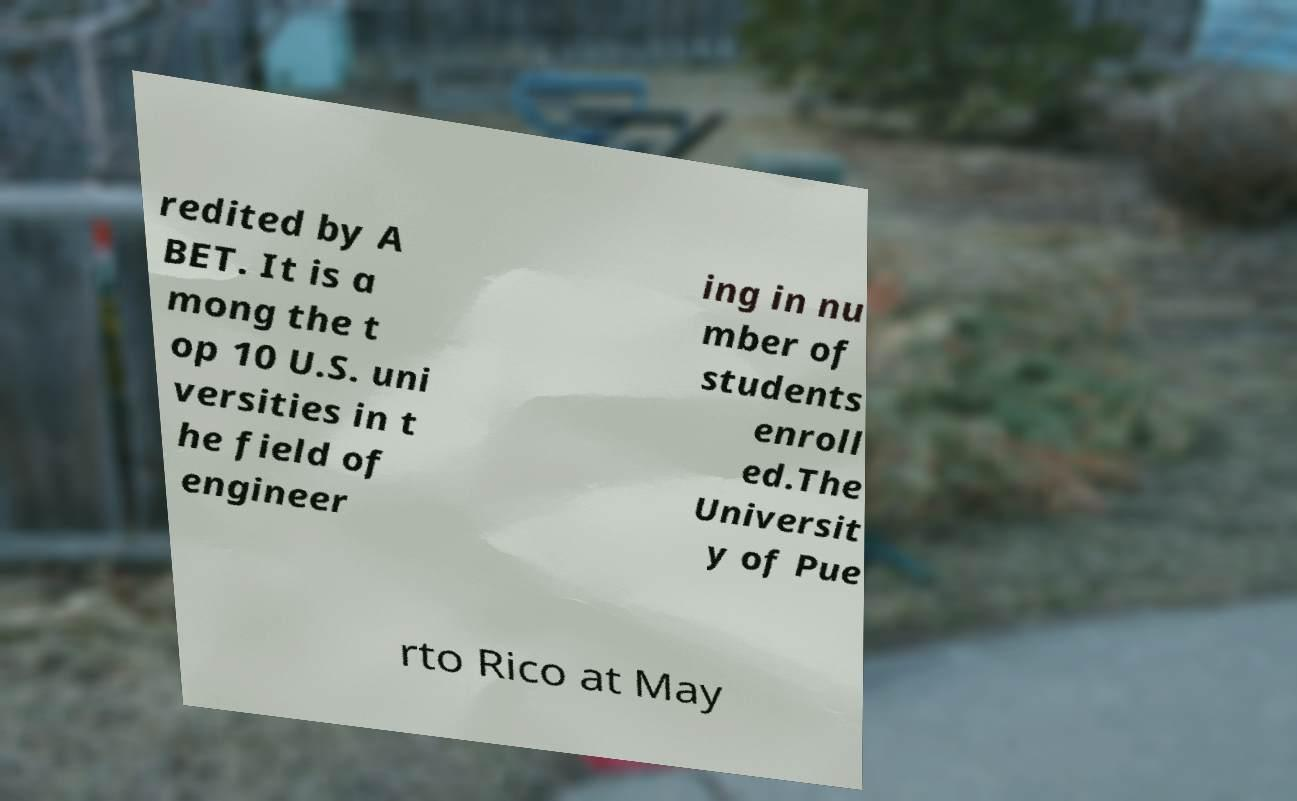There's text embedded in this image that I need extracted. Can you transcribe it verbatim? redited by A BET. It is a mong the t op 10 U.S. uni versities in t he field of engineer ing in nu mber of students enroll ed.The Universit y of Pue rto Rico at May 